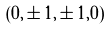<formula> <loc_0><loc_0><loc_500><loc_500>( 0 , \pm 1 , \pm 1 , 0 )</formula> 